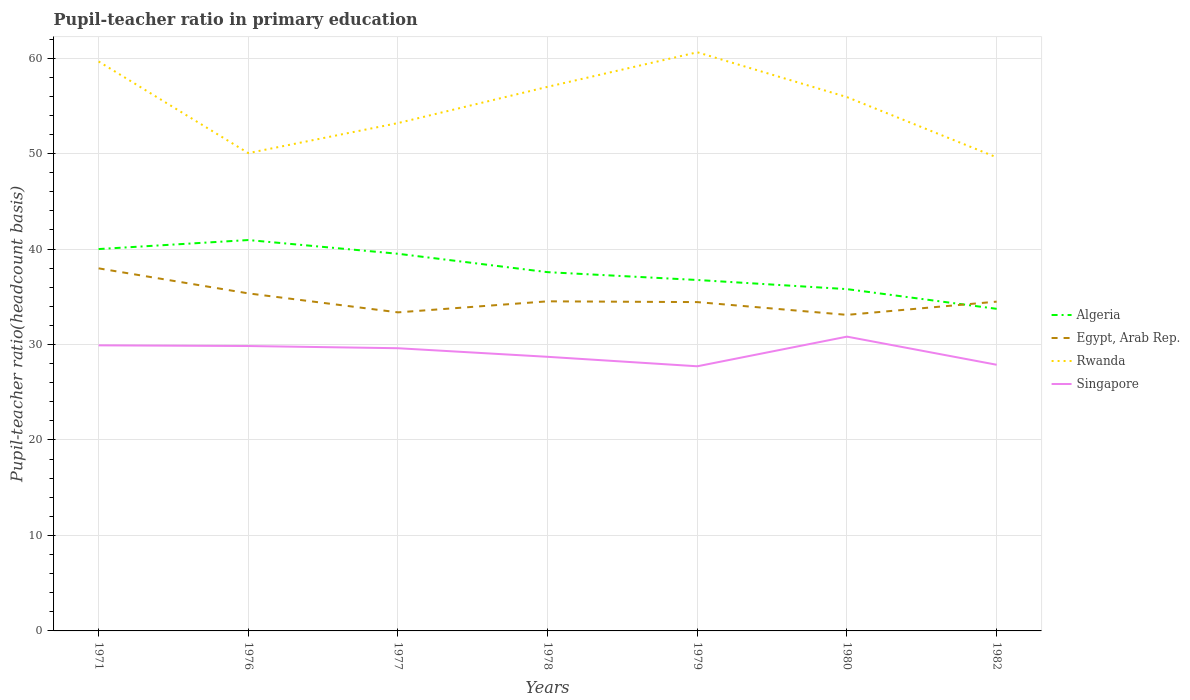How many different coloured lines are there?
Keep it short and to the point. 4. Across all years, what is the maximum pupil-teacher ratio in primary education in Algeria?
Give a very brief answer. 33.74. What is the total pupil-teacher ratio in primary education in Rwanda in the graph?
Offer a very short reply. 0.45. What is the difference between the highest and the second highest pupil-teacher ratio in primary education in Egypt, Arab Rep.?
Your response must be concise. 4.87. Is the pupil-teacher ratio in primary education in Algeria strictly greater than the pupil-teacher ratio in primary education in Singapore over the years?
Offer a terse response. No. How many years are there in the graph?
Make the answer very short. 7. What is the difference between two consecutive major ticks on the Y-axis?
Give a very brief answer. 10. Does the graph contain any zero values?
Provide a succinct answer. No. Does the graph contain grids?
Provide a short and direct response. Yes. Where does the legend appear in the graph?
Your response must be concise. Center right. What is the title of the graph?
Make the answer very short. Pupil-teacher ratio in primary education. Does "Luxembourg" appear as one of the legend labels in the graph?
Give a very brief answer. No. What is the label or title of the X-axis?
Keep it short and to the point. Years. What is the label or title of the Y-axis?
Provide a short and direct response. Pupil-teacher ratio(headcount basis). What is the Pupil-teacher ratio(headcount basis) of Algeria in 1971?
Keep it short and to the point. 40. What is the Pupil-teacher ratio(headcount basis) in Egypt, Arab Rep. in 1971?
Provide a short and direct response. 37.98. What is the Pupil-teacher ratio(headcount basis) in Rwanda in 1971?
Provide a short and direct response. 59.65. What is the Pupil-teacher ratio(headcount basis) of Singapore in 1971?
Make the answer very short. 29.92. What is the Pupil-teacher ratio(headcount basis) of Algeria in 1976?
Keep it short and to the point. 40.95. What is the Pupil-teacher ratio(headcount basis) of Egypt, Arab Rep. in 1976?
Your answer should be very brief. 35.36. What is the Pupil-teacher ratio(headcount basis) of Rwanda in 1976?
Your answer should be very brief. 50.05. What is the Pupil-teacher ratio(headcount basis) of Singapore in 1976?
Ensure brevity in your answer.  29.84. What is the Pupil-teacher ratio(headcount basis) of Algeria in 1977?
Give a very brief answer. 39.51. What is the Pupil-teacher ratio(headcount basis) of Egypt, Arab Rep. in 1977?
Give a very brief answer. 33.37. What is the Pupil-teacher ratio(headcount basis) of Rwanda in 1977?
Offer a very short reply. 53.2. What is the Pupil-teacher ratio(headcount basis) of Singapore in 1977?
Give a very brief answer. 29.61. What is the Pupil-teacher ratio(headcount basis) in Algeria in 1978?
Ensure brevity in your answer.  37.58. What is the Pupil-teacher ratio(headcount basis) in Egypt, Arab Rep. in 1978?
Make the answer very short. 34.53. What is the Pupil-teacher ratio(headcount basis) of Rwanda in 1978?
Ensure brevity in your answer.  57. What is the Pupil-teacher ratio(headcount basis) of Singapore in 1978?
Your answer should be very brief. 28.71. What is the Pupil-teacher ratio(headcount basis) of Algeria in 1979?
Keep it short and to the point. 36.76. What is the Pupil-teacher ratio(headcount basis) of Egypt, Arab Rep. in 1979?
Your response must be concise. 34.45. What is the Pupil-teacher ratio(headcount basis) of Rwanda in 1979?
Make the answer very short. 60.61. What is the Pupil-teacher ratio(headcount basis) of Singapore in 1979?
Your response must be concise. 27.72. What is the Pupil-teacher ratio(headcount basis) in Algeria in 1980?
Give a very brief answer. 35.8. What is the Pupil-teacher ratio(headcount basis) in Egypt, Arab Rep. in 1980?
Provide a short and direct response. 33.11. What is the Pupil-teacher ratio(headcount basis) in Rwanda in 1980?
Give a very brief answer. 55.92. What is the Pupil-teacher ratio(headcount basis) in Singapore in 1980?
Provide a short and direct response. 30.83. What is the Pupil-teacher ratio(headcount basis) in Algeria in 1982?
Give a very brief answer. 33.74. What is the Pupil-teacher ratio(headcount basis) in Egypt, Arab Rep. in 1982?
Your answer should be compact. 34.49. What is the Pupil-teacher ratio(headcount basis) in Rwanda in 1982?
Offer a very short reply. 49.61. What is the Pupil-teacher ratio(headcount basis) in Singapore in 1982?
Offer a terse response. 27.88. Across all years, what is the maximum Pupil-teacher ratio(headcount basis) in Algeria?
Make the answer very short. 40.95. Across all years, what is the maximum Pupil-teacher ratio(headcount basis) in Egypt, Arab Rep.?
Keep it short and to the point. 37.98. Across all years, what is the maximum Pupil-teacher ratio(headcount basis) of Rwanda?
Offer a very short reply. 60.61. Across all years, what is the maximum Pupil-teacher ratio(headcount basis) of Singapore?
Make the answer very short. 30.83. Across all years, what is the minimum Pupil-teacher ratio(headcount basis) of Algeria?
Provide a succinct answer. 33.74. Across all years, what is the minimum Pupil-teacher ratio(headcount basis) of Egypt, Arab Rep.?
Offer a terse response. 33.11. Across all years, what is the minimum Pupil-teacher ratio(headcount basis) in Rwanda?
Give a very brief answer. 49.61. Across all years, what is the minimum Pupil-teacher ratio(headcount basis) of Singapore?
Your response must be concise. 27.72. What is the total Pupil-teacher ratio(headcount basis) in Algeria in the graph?
Give a very brief answer. 264.34. What is the total Pupil-teacher ratio(headcount basis) of Egypt, Arab Rep. in the graph?
Your response must be concise. 243.28. What is the total Pupil-teacher ratio(headcount basis) in Rwanda in the graph?
Offer a terse response. 386.04. What is the total Pupil-teacher ratio(headcount basis) in Singapore in the graph?
Provide a short and direct response. 204.52. What is the difference between the Pupil-teacher ratio(headcount basis) of Algeria in 1971 and that in 1976?
Your answer should be compact. -0.95. What is the difference between the Pupil-teacher ratio(headcount basis) of Egypt, Arab Rep. in 1971 and that in 1976?
Offer a terse response. 2.62. What is the difference between the Pupil-teacher ratio(headcount basis) in Rwanda in 1971 and that in 1976?
Your answer should be very brief. 9.6. What is the difference between the Pupil-teacher ratio(headcount basis) in Singapore in 1971 and that in 1976?
Your response must be concise. 0.07. What is the difference between the Pupil-teacher ratio(headcount basis) of Algeria in 1971 and that in 1977?
Offer a terse response. 0.49. What is the difference between the Pupil-teacher ratio(headcount basis) in Egypt, Arab Rep. in 1971 and that in 1977?
Provide a succinct answer. 4.61. What is the difference between the Pupil-teacher ratio(headcount basis) in Rwanda in 1971 and that in 1977?
Your answer should be very brief. 6.45. What is the difference between the Pupil-teacher ratio(headcount basis) in Singapore in 1971 and that in 1977?
Keep it short and to the point. 0.3. What is the difference between the Pupil-teacher ratio(headcount basis) in Algeria in 1971 and that in 1978?
Offer a very short reply. 2.42. What is the difference between the Pupil-teacher ratio(headcount basis) in Egypt, Arab Rep. in 1971 and that in 1978?
Provide a short and direct response. 3.45. What is the difference between the Pupil-teacher ratio(headcount basis) of Rwanda in 1971 and that in 1978?
Offer a terse response. 2.66. What is the difference between the Pupil-teacher ratio(headcount basis) of Singapore in 1971 and that in 1978?
Offer a very short reply. 1.2. What is the difference between the Pupil-teacher ratio(headcount basis) of Algeria in 1971 and that in 1979?
Your answer should be very brief. 3.24. What is the difference between the Pupil-teacher ratio(headcount basis) of Egypt, Arab Rep. in 1971 and that in 1979?
Keep it short and to the point. 3.54. What is the difference between the Pupil-teacher ratio(headcount basis) of Rwanda in 1971 and that in 1979?
Your answer should be very brief. -0.96. What is the difference between the Pupil-teacher ratio(headcount basis) of Singapore in 1971 and that in 1979?
Your response must be concise. 2.19. What is the difference between the Pupil-teacher ratio(headcount basis) in Algeria in 1971 and that in 1980?
Make the answer very short. 4.2. What is the difference between the Pupil-teacher ratio(headcount basis) of Egypt, Arab Rep. in 1971 and that in 1980?
Keep it short and to the point. 4.87. What is the difference between the Pupil-teacher ratio(headcount basis) of Rwanda in 1971 and that in 1980?
Make the answer very short. 3.73. What is the difference between the Pupil-teacher ratio(headcount basis) of Singapore in 1971 and that in 1980?
Keep it short and to the point. -0.91. What is the difference between the Pupil-teacher ratio(headcount basis) of Algeria in 1971 and that in 1982?
Give a very brief answer. 6.26. What is the difference between the Pupil-teacher ratio(headcount basis) of Egypt, Arab Rep. in 1971 and that in 1982?
Your answer should be compact. 3.49. What is the difference between the Pupil-teacher ratio(headcount basis) of Rwanda in 1971 and that in 1982?
Your answer should be compact. 10.05. What is the difference between the Pupil-teacher ratio(headcount basis) in Singapore in 1971 and that in 1982?
Keep it short and to the point. 2.03. What is the difference between the Pupil-teacher ratio(headcount basis) in Algeria in 1976 and that in 1977?
Offer a very short reply. 1.44. What is the difference between the Pupil-teacher ratio(headcount basis) in Egypt, Arab Rep. in 1976 and that in 1977?
Your response must be concise. 1.99. What is the difference between the Pupil-teacher ratio(headcount basis) of Rwanda in 1976 and that in 1977?
Make the answer very short. -3.15. What is the difference between the Pupil-teacher ratio(headcount basis) of Singapore in 1976 and that in 1977?
Provide a succinct answer. 0.23. What is the difference between the Pupil-teacher ratio(headcount basis) of Algeria in 1976 and that in 1978?
Your answer should be compact. 3.36. What is the difference between the Pupil-teacher ratio(headcount basis) in Egypt, Arab Rep. in 1976 and that in 1978?
Your response must be concise. 0.83. What is the difference between the Pupil-teacher ratio(headcount basis) in Rwanda in 1976 and that in 1978?
Your answer should be very brief. -6.94. What is the difference between the Pupil-teacher ratio(headcount basis) in Singapore in 1976 and that in 1978?
Make the answer very short. 1.13. What is the difference between the Pupil-teacher ratio(headcount basis) in Algeria in 1976 and that in 1979?
Ensure brevity in your answer.  4.18. What is the difference between the Pupil-teacher ratio(headcount basis) of Egypt, Arab Rep. in 1976 and that in 1979?
Your answer should be very brief. 0.91. What is the difference between the Pupil-teacher ratio(headcount basis) in Rwanda in 1976 and that in 1979?
Offer a terse response. -10.56. What is the difference between the Pupil-teacher ratio(headcount basis) in Singapore in 1976 and that in 1979?
Give a very brief answer. 2.12. What is the difference between the Pupil-teacher ratio(headcount basis) of Algeria in 1976 and that in 1980?
Your response must be concise. 5.14. What is the difference between the Pupil-teacher ratio(headcount basis) in Egypt, Arab Rep. in 1976 and that in 1980?
Make the answer very short. 2.25. What is the difference between the Pupil-teacher ratio(headcount basis) in Rwanda in 1976 and that in 1980?
Keep it short and to the point. -5.87. What is the difference between the Pupil-teacher ratio(headcount basis) in Singapore in 1976 and that in 1980?
Ensure brevity in your answer.  -0.98. What is the difference between the Pupil-teacher ratio(headcount basis) in Algeria in 1976 and that in 1982?
Provide a short and direct response. 7.21. What is the difference between the Pupil-teacher ratio(headcount basis) in Egypt, Arab Rep. in 1976 and that in 1982?
Your answer should be compact. 0.87. What is the difference between the Pupil-teacher ratio(headcount basis) of Rwanda in 1976 and that in 1982?
Offer a very short reply. 0.45. What is the difference between the Pupil-teacher ratio(headcount basis) in Singapore in 1976 and that in 1982?
Keep it short and to the point. 1.96. What is the difference between the Pupil-teacher ratio(headcount basis) in Algeria in 1977 and that in 1978?
Give a very brief answer. 1.93. What is the difference between the Pupil-teacher ratio(headcount basis) of Egypt, Arab Rep. in 1977 and that in 1978?
Give a very brief answer. -1.16. What is the difference between the Pupil-teacher ratio(headcount basis) in Rwanda in 1977 and that in 1978?
Your answer should be compact. -3.8. What is the difference between the Pupil-teacher ratio(headcount basis) of Singapore in 1977 and that in 1978?
Your response must be concise. 0.9. What is the difference between the Pupil-teacher ratio(headcount basis) in Algeria in 1977 and that in 1979?
Keep it short and to the point. 2.75. What is the difference between the Pupil-teacher ratio(headcount basis) of Egypt, Arab Rep. in 1977 and that in 1979?
Make the answer very short. -1.08. What is the difference between the Pupil-teacher ratio(headcount basis) in Rwanda in 1977 and that in 1979?
Your answer should be compact. -7.42. What is the difference between the Pupil-teacher ratio(headcount basis) in Singapore in 1977 and that in 1979?
Give a very brief answer. 1.89. What is the difference between the Pupil-teacher ratio(headcount basis) of Algeria in 1977 and that in 1980?
Offer a very short reply. 3.7. What is the difference between the Pupil-teacher ratio(headcount basis) in Egypt, Arab Rep. in 1977 and that in 1980?
Your response must be concise. 0.26. What is the difference between the Pupil-teacher ratio(headcount basis) in Rwanda in 1977 and that in 1980?
Your answer should be very brief. -2.72. What is the difference between the Pupil-teacher ratio(headcount basis) in Singapore in 1977 and that in 1980?
Provide a short and direct response. -1.21. What is the difference between the Pupil-teacher ratio(headcount basis) of Algeria in 1977 and that in 1982?
Your answer should be very brief. 5.77. What is the difference between the Pupil-teacher ratio(headcount basis) of Egypt, Arab Rep. in 1977 and that in 1982?
Provide a succinct answer. -1.12. What is the difference between the Pupil-teacher ratio(headcount basis) of Rwanda in 1977 and that in 1982?
Offer a terse response. 3.59. What is the difference between the Pupil-teacher ratio(headcount basis) in Singapore in 1977 and that in 1982?
Keep it short and to the point. 1.73. What is the difference between the Pupil-teacher ratio(headcount basis) of Algeria in 1978 and that in 1979?
Provide a succinct answer. 0.82. What is the difference between the Pupil-teacher ratio(headcount basis) of Egypt, Arab Rep. in 1978 and that in 1979?
Make the answer very short. 0.08. What is the difference between the Pupil-teacher ratio(headcount basis) in Rwanda in 1978 and that in 1979?
Keep it short and to the point. -3.62. What is the difference between the Pupil-teacher ratio(headcount basis) in Singapore in 1978 and that in 1979?
Give a very brief answer. 0.99. What is the difference between the Pupil-teacher ratio(headcount basis) of Algeria in 1978 and that in 1980?
Your answer should be compact. 1.78. What is the difference between the Pupil-teacher ratio(headcount basis) of Egypt, Arab Rep. in 1978 and that in 1980?
Offer a terse response. 1.42. What is the difference between the Pupil-teacher ratio(headcount basis) in Rwanda in 1978 and that in 1980?
Your answer should be very brief. 1.08. What is the difference between the Pupil-teacher ratio(headcount basis) in Singapore in 1978 and that in 1980?
Ensure brevity in your answer.  -2.11. What is the difference between the Pupil-teacher ratio(headcount basis) in Algeria in 1978 and that in 1982?
Ensure brevity in your answer.  3.84. What is the difference between the Pupil-teacher ratio(headcount basis) in Egypt, Arab Rep. in 1978 and that in 1982?
Offer a very short reply. 0.03. What is the difference between the Pupil-teacher ratio(headcount basis) in Rwanda in 1978 and that in 1982?
Your response must be concise. 7.39. What is the difference between the Pupil-teacher ratio(headcount basis) of Singapore in 1978 and that in 1982?
Provide a short and direct response. 0.83. What is the difference between the Pupil-teacher ratio(headcount basis) of Algeria in 1979 and that in 1980?
Make the answer very short. 0.96. What is the difference between the Pupil-teacher ratio(headcount basis) in Egypt, Arab Rep. in 1979 and that in 1980?
Keep it short and to the point. 1.34. What is the difference between the Pupil-teacher ratio(headcount basis) in Rwanda in 1979 and that in 1980?
Offer a very short reply. 4.7. What is the difference between the Pupil-teacher ratio(headcount basis) of Singapore in 1979 and that in 1980?
Your answer should be compact. -3.11. What is the difference between the Pupil-teacher ratio(headcount basis) of Algeria in 1979 and that in 1982?
Make the answer very short. 3.02. What is the difference between the Pupil-teacher ratio(headcount basis) in Egypt, Arab Rep. in 1979 and that in 1982?
Offer a terse response. -0.05. What is the difference between the Pupil-teacher ratio(headcount basis) in Rwanda in 1979 and that in 1982?
Your response must be concise. 11.01. What is the difference between the Pupil-teacher ratio(headcount basis) in Singapore in 1979 and that in 1982?
Give a very brief answer. -0.16. What is the difference between the Pupil-teacher ratio(headcount basis) in Algeria in 1980 and that in 1982?
Provide a short and direct response. 2.06. What is the difference between the Pupil-teacher ratio(headcount basis) of Egypt, Arab Rep. in 1980 and that in 1982?
Ensure brevity in your answer.  -1.39. What is the difference between the Pupil-teacher ratio(headcount basis) in Rwanda in 1980 and that in 1982?
Offer a very short reply. 6.31. What is the difference between the Pupil-teacher ratio(headcount basis) in Singapore in 1980 and that in 1982?
Provide a short and direct response. 2.95. What is the difference between the Pupil-teacher ratio(headcount basis) in Algeria in 1971 and the Pupil-teacher ratio(headcount basis) in Egypt, Arab Rep. in 1976?
Keep it short and to the point. 4.64. What is the difference between the Pupil-teacher ratio(headcount basis) of Algeria in 1971 and the Pupil-teacher ratio(headcount basis) of Rwanda in 1976?
Your answer should be compact. -10.05. What is the difference between the Pupil-teacher ratio(headcount basis) in Algeria in 1971 and the Pupil-teacher ratio(headcount basis) in Singapore in 1976?
Give a very brief answer. 10.16. What is the difference between the Pupil-teacher ratio(headcount basis) in Egypt, Arab Rep. in 1971 and the Pupil-teacher ratio(headcount basis) in Rwanda in 1976?
Give a very brief answer. -12.07. What is the difference between the Pupil-teacher ratio(headcount basis) in Egypt, Arab Rep. in 1971 and the Pupil-teacher ratio(headcount basis) in Singapore in 1976?
Your answer should be compact. 8.14. What is the difference between the Pupil-teacher ratio(headcount basis) of Rwanda in 1971 and the Pupil-teacher ratio(headcount basis) of Singapore in 1976?
Your answer should be compact. 29.81. What is the difference between the Pupil-teacher ratio(headcount basis) of Algeria in 1971 and the Pupil-teacher ratio(headcount basis) of Egypt, Arab Rep. in 1977?
Offer a very short reply. 6.63. What is the difference between the Pupil-teacher ratio(headcount basis) of Algeria in 1971 and the Pupil-teacher ratio(headcount basis) of Rwanda in 1977?
Make the answer very short. -13.2. What is the difference between the Pupil-teacher ratio(headcount basis) of Algeria in 1971 and the Pupil-teacher ratio(headcount basis) of Singapore in 1977?
Provide a succinct answer. 10.39. What is the difference between the Pupil-teacher ratio(headcount basis) of Egypt, Arab Rep. in 1971 and the Pupil-teacher ratio(headcount basis) of Rwanda in 1977?
Make the answer very short. -15.22. What is the difference between the Pupil-teacher ratio(headcount basis) of Egypt, Arab Rep. in 1971 and the Pupil-teacher ratio(headcount basis) of Singapore in 1977?
Your response must be concise. 8.37. What is the difference between the Pupil-teacher ratio(headcount basis) in Rwanda in 1971 and the Pupil-teacher ratio(headcount basis) in Singapore in 1977?
Offer a terse response. 30.04. What is the difference between the Pupil-teacher ratio(headcount basis) in Algeria in 1971 and the Pupil-teacher ratio(headcount basis) in Egypt, Arab Rep. in 1978?
Your answer should be very brief. 5.47. What is the difference between the Pupil-teacher ratio(headcount basis) in Algeria in 1971 and the Pupil-teacher ratio(headcount basis) in Rwanda in 1978?
Ensure brevity in your answer.  -17. What is the difference between the Pupil-teacher ratio(headcount basis) of Algeria in 1971 and the Pupil-teacher ratio(headcount basis) of Singapore in 1978?
Provide a short and direct response. 11.29. What is the difference between the Pupil-teacher ratio(headcount basis) in Egypt, Arab Rep. in 1971 and the Pupil-teacher ratio(headcount basis) in Rwanda in 1978?
Your answer should be very brief. -19.02. What is the difference between the Pupil-teacher ratio(headcount basis) of Egypt, Arab Rep. in 1971 and the Pupil-teacher ratio(headcount basis) of Singapore in 1978?
Offer a very short reply. 9.27. What is the difference between the Pupil-teacher ratio(headcount basis) of Rwanda in 1971 and the Pupil-teacher ratio(headcount basis) of Singapore in 1978?
Give a very brief answer. 30.94. What is the difference between the Pupil-teacher ratio(headcount basis) in Algeria in 1971 and the Pupil-teacher ratio(headcount basis) in Egypt, Arab Rep. in 1979?
Ensure brevity in your answer.  5.56. What is the difference between the Pupil-teacher ratio(headcount basis) of Algeria in 1971 and the Pupil-teacher ratio(headcount basis) of Rwanda in 1979?
Provide a succinct answer. -20.61. What is the difference between the Pupil-teacher ratio(headcount basis) in Algeria in 1971 and the Pupil-teacher ratio(headcount basis) in Singapore in 1979?
Offer a very short reply. 12.28. What is the difference between the Pupil-teacher ratio(headcount basis) of Egypt, Arab Rep. in 1971 and the Pupil-teacher ratio(headcount basis) of Rwanda in 1979?
Provide a short and direct response. -22.63. What is the difference between the Pupil-teacher ratio(headcount basis) of Egypt, Arab Rep. in 1971 and the Pupil-teacher ratio(headcount basis) of Singapore in 1979?
Offer a very short reply. 10.26. What is the difference between the Pupil-teacher ratio(headcount basis) in Rwanda in 1971 and the Pupil-teacher ratio(headcount basis) in Singapore in 1979?
Offer a terse response. 31.93. What is the difference between the Pupil-teacher ratio(headcount basis) in Algeria in 1971 and the Pupil-teacher ratio(headcount basis) in Egypt, Arab Rep. in 1980?
Give a very brief answer. 6.89. What is the difference between the Pupil-teacher ratio(headcount basis) in Algeria in 1971 and the Pupil-teacher ratio(headcount basis) in Rwanda in 1980?
Offer a terse response. -15.92. What is the difference between the Pupil-teacher ratio(headcount basis) in Algeria in 1971 and the Pupil-teacher ratio(headcount basis) in Singapore in 1980?
Give a very brief answer. 9.17. What is the difference between the Pupil-teacher ratio(headcount basis) of Egypt, Arab Rep. in 1971 and the Pupil-teacher ratio(headcount basis) of Rwanda in 1980?
Make the answer very short. -17.94. What is the difference between the Pupil-teacher ratio(headcount basis) in Egypt, Arab Rep. in 1971 and the Pupil-teacher ratio(headcount basis) in Singapore in 1980?
Make the answer very short. 7.15. What is the difference between the Pupil-teacher ratio(headcount basis) of Rwanda in 1971 and the Pupil-teacher ratio(headcount basis) of Singapore in 1980?
Your answer should be very brief. 28.82. What is the difference between the Pupil-teacher ratio(headcount basis) of Algeria in 1971 and the Pupil-teacher ratio(headcount basis) of Egypt, Arab Rep. in 1982?
Ensure brevity in your answer.  5.51. What is the difference between the Pupil-teacher ratio(headcount basis) in Algeria in 1971 and the Pupil-teacher ratio(headcount basis) in Rwanda in 1982?
Make the answer very short. -9.61. What is the difference between the Pupil-teacher ratio(headcount basis) in Algeria in 1971 and the Pupil-teacher ratio(headcount basis) in Singapore in 1982?
Your answer should be very brief. 12.12. What is the difference between the Pupil-teacher ratio(headcount basis) in Egypt, Arab Rep. in 1971 and the Pupil-teacher ratio(headcount basis) in Rwanda in 1982?
Your answer should be compact. -11.63. What is the difference between the Pupil-teacher ratio(headcount basis) of Egypt, Arab Rep. in 1971 and the Pupil-teacher ratio(headcount basis) of Singapore in 1982?
Make the answer very short. 10.1. What is the difference between the Pupil-teacher ratio(headcount basis) in Rwanda in 1971 and the Pupil-teacher ratio(headcount basis) in Singapore in 1982?
Keep it short and to the point. 31.77. What is the difference between the Pupil-teacher ratio(headcount basis) of Algeria in 1976 and the Pupil-teacher ratio(headcount basis) of Egypt, Arab Rep. in 1977?
Keep it short and to the point. 7.58. What is the difference between the Pupil-teacher ratio(headcount basis) of Algeria in 1976 and the Pupil-teacher ratio(headcount basis) of Rwanda in 1977?
Your answer should be very brief. -12.25. What is the difference between the Pupil-teacher ratio(headcount basis) of Algeria in 1976 and the Pupil-teacher ratio(headcount basis) of Singapore in 1977?
Your answer should be very brief. 11.33. What is the difference between the Pupil-teacher ratio(headcount basis) in Egypt, Arab Rep. in 1976 and the Pupil-teacher ratio(headcount basis) in Rwanda in 1977?
Give a very brief answer. -17.84. What is the difference between the Pupil-teacher ratio(headcount basis) in Egypt, Arab Rep. in 1976 and the Pupil-teacher ratio(headcount basis) in Singapore in 1977?
Offer a very short reply. 5.75. What is the difference between the Pupil-teacher ratio(headcount basis) in Rwanda in 1976 and the Pupil-teacher ratio(headcount basis) in Singapore in 1977?
Keep it short and to the point. 20.44. What is the difference between the Pupil-teacher ratio(headcount basis) of Algeria in 1976 and the Pupil-teacher ratio(headcount basis) of Egypt, Arab Rep. in 1978?
Make the answer very short. 6.42. What is the difference between the Pupil-teacher ratio(headcount basis) in Algeria in 1976 and the Pupil-teacher ratio(headcount basis) in Rwanda in 1978?
Your answer should be compact. -16.05. What is the difference between the Pupil-teacher ratio(headcount basis) of Algeria in 1976 and the Pupil-teacher ratio(headcount basis) of Singapore in 1978?
Keep it short and to the point. 12.23. What is the difference between the Pupil-teacher ratio(headcount basis) in Egypt, Arab Rep. in 1976 and the Pupil-teacher ratio(headcount basis) in Rwanda in 1978?
Ensure brevity in your answer.  -21.64. What is the difference between the Pupil-teacher ratio(headcount basis) in Egypt, Arab Rep. in 1976 and the Pupil-teacher ratio(headcount basis) in Singapore in 1978?
Offer a terse response. 6.64. What is the difference between the Pupil-teacher ratio(headcount basis) of Rwanda in 1976 and the Pupil-teacher ratio(headcount basis) of Singapore in 1978?
Your response must be concise. 21.34. What is the difference between the Pupil-teacher ratio(headcount basis) in Algeria in 1976 and the Pupil-teacher ratio(headcount basis) in Egypt, Arab Rep. in 1979?
Your answer should be very brief. 6.5. What is the difference between the Pupil-teacher ratio(headcount basis) of Algeria in 1976 and the Pupil-teacher ratio(headcount basis) of Rwanda in 1979?
Offer a very short reply. -19.67. What is the difference between the Pupil-teacher ratio(headcount basis) of Algeria in 1976 and the Pupil-teacher ratio(headcount basis) of Singapore in 1979?
Your response must be concise. 13.22. What is the difference between the Pupil-teacher ratio(headcount basis) of Egypt, Arab Rep. in 1976 and the Pupil-teacher ratio(headcount basis) of Rwanda in 1979?
Your answer should be very brief. -25.26. What is the difference between the Pupil-teacher ratio(headcount basis) of Egypt, Arab Rep. in 1976 and the Pupil-teacher ratio(headcount basis) of Singapore in 1979?
Offer a terse response. 7.64. What is the difference between the Pupil-teacher ratio(headcount basis) in Rwanda in 1976 and the Pupil-teacher ratio(headcount basis) in Singapore in 1979?
Provide a succinct answer. 22.33. What is the difference between the Pupil-teacher ratio(headcount basis) in Algeria in 1976 and the Pupil-teacher ratio(headcount basis) in Egypt, Arab Rep. in 1980?
Provide a succinct answer. 7.84. What is the difference between the Pupil-teacher ratio(headcount basis) in Algeria in 1976 and the Pupil-teacher ratio(headcount basis) in Rwanda in 1980?
Make the answer very short. -14.97. What is the difference between the Pupil-teacher ratio(headcount basis) of Algeria in 1976 and the Pupil-teacher ratio(headcount basis) of Singapore in 1980?
Keep it short and to the point. 10.12. What is the difference between the Pupil-teacher ratio(headcount basis) in Egypt, Arab Rep. in 1976 and the Pupil-teacher ratio(headcount basis) in Rwanda in 1980?
Your response must be concise. -20.56. What is the difference between the Pupil-teacher ratio(headcount basis) of Egypt, Arab Rep. in 1976 and the Pupil-teacher ratio(headcount basis) of Singapore in 1980?
Your answer should be very brief. 4.53. What is the difference between the Pupil-teacher ratio(headcount basis) in Rwanda in 1976 and the Pupil-teacher ratio(headcount basis) in Singapore in 1980?
Keep it short and to the point. 19.22. What is the difference between the Pupil-teacher ratio(headcount basis) of Algeria in 1976 and the Pupil-teacher ratio(headcount basis) of Egypt, Arab Rep. in 1982?
Offer a very short reply. 6.45. What is the difference between the Pupil-teacher ratio(headcount basis) of Algeria in 1976 and the Pupil-teacher ratio(headcount basis) of Rwanda in 1982?
Offer a very short reply. -8.66. What is the difference between the Pupil-teacher ratio(headcount basis) in Algeria in 1976 and the Pupil-teacher ratio(headcount basis) in Singapore in 1982?
Make the answer very short. 13.07. What is the difference between the Pupil-teacher ratio(headcount basis) of Egypt, Arab Rep. in 1976 and the Pupil-teacher ratio(headcount basis) of Rwanda in 1982?
Provide a short and direct response. -14.25. What is the difference between the Pupil-teacher ratio(headcount basis) in Egypt, Arab Rep. in 1976 and the Pupil-teacher ratio(headcount basis) in Singapore in 1982?
Provide a short and direct response. 7.48. What is the difference between the Pupil-teacher ratio(headcount basis) of Rwanda in 1976 and the Pupil-teacher ratio(headcount basis) of Singapore in 1982?
Keep it short and to the point. 22.17. What is the difference between the Pupil-teacher ratio(headcount basis) in Algeria in 1977 and the Pupil-teacher ratio(headcount basis) in Egypt, Arab Rep. in 1978?
Your answer should be very brief. 4.98. What is the difference between the Pupil-teacher ratio(headcount basis) of Algeria in 1977 and the Pupil-teacher ratio(headcount basis) of Rwanda in 1978?
Ensure brevity in your answer.  -17.49. What is the difference between the Pupil-teacher ratio(headcount basis) of Algeria in 1977 and the Pupil-teacher ratio(headcount basis) of Singapore in 1978?
Make the answer very short. 10.79. What is the difference between the Pupil-teacher ratio(headcount basis) in Egypt, Arab Rep. in 1977 and the Pupil-teacher ratio(headcount basis) in Rwanda in 1978?
Your answer should be very brief. -23.63. What is the difference between the Pupil-teacher ratio(headcount basis) of Egypt, Arab Rep. in 1977 and the Pupil-teacher ratio(headcount basis) of Singapore in 1978?
Provide a short and direct response. 4.66. What is the difference between the Pupil-teacher ratio(headcount basis) of Rwanda in 1977 and the Pupil-teacher ratio(headcount basis) of Singapore in 1978?
Ensure brevity in your answer.  24.48. What is the difference between the Pupil-teacher ratio(headcount basis) in Algeria in 1977 and the Pupil-teacher ratio(headcount basis) in Egypt, Arab Rep. in 1979?
Offer a very short reply. 5.06. What is the difference between the Pupil-teacher ratio(headcount basis) of Algeria in 1977 and the Pupil-teacher ratio(headcount basis) of Rwanda in 1979?
Your answer should be very brief. -21.11. What is the difference between the Pupil-teacher ratio(headcount basis) in Algeria in 1977 and the Pupil-teacher ratio(headcount basis) in Singapore in 1979?
Provide a short and direct response. 11.79. What is the difference between the Pupil-teacher ratio(headcount basis) in Egypt, Arab Rep. in 1977 and the Pupil-teacher ratio(headcount basis) in Rwanda in 1979?
Offer a very short reply. -27.25. What is the difference between the Pupil-teacher ratio(headcount basis) of Egypt, Arab Rep. in 1977 and the Pupil-teacher ratio(headcount basis) of Singapore in 1979?
Keep it short and to the point. 5.65. What is the difference between the Pupil-teacher ratio(headcount basis) in Rwanda in 1977 and the Pupil-teacher ratio(headcount basis) in Singapore in 1979?
Give a very brief answer. 25.48. What is the difference between the Pupil-teacher ratio(headcount basis) of Algeria in 1977 and the Pupil-teacher ratio(headcount basis) of Egypt, Arab Rep. in 1980?
Offer a terse response. 6.4. What is the difference between the Pupil-teacher ratio(headcount basis) of Algeria in 1977 and the Pupil-teacher ratio(headcount basis) of Rwanda in 1980?
Offer a very short reply. -16.41. What is the difference between the Pupil-teacher ratio(headcount basis) in Algeria in 1977 and the Pupil-teacher ratio(headcount basis) in Singapore in 1980?
Your answer should be very brief. 8.68. What is the difference between the Pupil-teacher ratio(headcount basis) of Egypt, Arab Rep. in 1977 and the Pupil-teacher ratio(headcount basis) of Rwanda in 1980?
Keep it short and to the point. -22.55. What is the difference between the Pupil-teacher ratio(headcount basis) of Egypt, Arab Rep. in 1977 and the Pupil-teacher ratio(headcount basis) of Singapore in 1980?
Your answer should be compact. 2.54. What is the difference between the Pupil-teacher ratio(headcount basis) in Rwanda in 1977 and the Pupil-teacher ratio(headcount basis) in Singapore in 1980?
Your answer should be compact. 22.37. What is the difference between the Pupil-teacher ratio(headcount basis) of Algeria in 1977 and the Pupil-teacher ratio(headcount basis) of Egypt, Arab Rep. in 1982?
Your answer should be very brief. 5.02. What is the difference between the Pupil-teacher ratio(headcount basis) of Algeria in 1977 and the Pupil-teacher ratio(headcount basis) of Rwanda in 1982?
Provide a short and direct response. -10.1. What is the difference between the Pupil-teacher ratio(headcount basis) in Algeria in 1977 and the Pupil-teacher ratio(headcount basis) in Singapore in 1982?
Provide a short and direct response. 11.63. What is the difference between the Pupil-teacher ratio(headcount basis) in Egypt, Arab Rep. in 1977 and the Pupil-teacher ratio(headcount basis) in Rwanda in 1982?
Ensure brevity in your answer.  -16.24. What is the difference between the Pupil-teacher ratio(headcount basis) of Egypt, Arab Rep. in 1977 and the Pupil-teacher ratio(headcount basis) of Singapore in 1982?
Your response must be concise. 5.49. What is the difference between the Pupil-teacher ratio(headcount basis) of Rwanda in 1977 and the Pupil-teacher ratio(headcount basis) of Singapore in 1982?
Keep it short and to the point. 25.32. What is the difference between the Pupil-teacher ratio(headcount basis) in Algeria in 1978 and the Pupil-teacher ratio(headcount basis) in Egypt, Arab Rep. in 1979?
Your response must be concise. 3.14. What is the difference between the Pupil-teacher ratio(headcount basis) in Algeria in 1978 and the Pupil-teacher ratio(headcount basis) in Rwanda in 1979?
Make the answer very short. -23.03. What is the difference between the Pupil-teacher ratio(headcount basis) in Algeria in 1978 and the Pupil-teacher ratio(headcount basis) in Singapore in 1979?
Give a very brief answer. 9.86. What is the difference between the Pupil-teacher ratio(headcount basis) of Egypt, Arab Rep. in 1978 and the Pupil-teacher ratio(headcount basis) of Rwanda in 1979?
Make the answer very short. -26.09. What is the difference between the Pupil-teacher ratio(headcount basis) of Egypt, Arab Rep. in 1978 and the Pupil-teacher ratio(headcount basis) of Singapore in 1979?
Provide a short and direct response. 6.8. What is the difference between the Pupil-teacher ratio(headcount basis) of Rwanda in 1978 and the Pupil-teacher ratio(headcount basis) of Singapore in 1979?
Give a very brief answer. 29.27. What is the difference between the Pupil-teacher ratio(headcount basis) of Algeria in 1978 and the Pupil-teacher ratio(headcount basis) of Egypt, Arab Rep. in 1980?
Provide a succinct answer. 4.47. What is the difference between the Pupil-teacher ratio(headcount basis) of Algeria in 1978 and the Pupil-teacher ratio(headcount basis) of Rwanda in 1980?
Your answer should be very brief. -18.34. What is the difference between the Pupil-teacher ratio(headcount basis) in Algeria in 1978 and the Pupil-teacher ratio(headcount basis) in Singapore in 1980?
Offer a terse response. 6.75. What is the difference between the Pupil-teacher ratio(headcount basis) in Egypt, Arab Rep. in 1978 and the Pupil-teacher ratio(headcount basis) in Rwanda in 1980?
Ensure brevity in your answer.  -21.39. What is the difference between the Pupil-teacher ratio(headcount basis) of Egypt, Arab Rep. in 1978 and the Pupil-teacher ratio(headcount basis) of Singapore in 1980?
Your response must be concise. 3.7. What is the difference between the Pupil-teacher ratio(headcount basis) of Rwanda in 1978 and the Pupil-teacher ratio(headcount basis) of Singapore in 1980?
Make the answer very short. 26.17. What is the difference between the Pupil-teacher ratio(headcount basis) in Algeria in 1978 and the Pupil-teacher ratio(headcount basis) in Egypt, Arab Rep. in 1982?
Your response must be concise. 3.09. What is the difference between the Pupil-teacher ratio(headcount basis) in Algeria in 1978 and the Pupil-teacher ratio(headcount basis) in Rwanda in 1982?
Provide a short and direct response. -12.03. What is the difference between the Pupil-teacher ratio(headcount basis) of Algeria in 1978 and the Pupil-teacher ratio(headcount basis) of Singapore in 1982?
Keep it short and to the point. 9.7. What is the difference between the Pupil-teacher ratio(headcount basis) in Egypt, Arab Rep. in 1978 and the Pupil-teacher ratio(headcount basis) in Rwanda in 1982?
Your response must be concise. -15.08. What is the difference between the Pupil-teacher ratio(headcount basis) in Egypt, Arab Rep. in 1978 and the Pupil-teacher ratio(headcount basis) in Singapore in 1982?
Provide a short and direct response. 6.65. What is the difference between the Pupil-teacher ratio(headcount basis) in Rwanda in 1978 and the Pupil-teacher ratio(headcount basis) in Singapore in 1982?
Your answer should be very brief. 29.12. What is the difference between the Pupil-teacher ratio(headcount basis) of Algeria in 1979 and the Pupil-teacher ratio(headcount basis) of Egypt, Arab Rep. in 1980?
Ensure brevity in your answer.  3.65. What is the difference between the Pupil-teacher ratio(headcount basis) in Algeria in 1979 and the Pupil-teacher ratio(headcount basis) in Rwanda in 1980?
Give a very brief answer. -19.16. What is the difference between the Pupil-teacher ratio(headcount basis) in Algeria in 1979 and the Pupil-teacher ratio(headcount basis) in Singapore in 1980?
Keep it short and to the point. 5.93. What is the difference between the Pupil-teacher ratio(headcount basis) in Egypt, Arab Rep. in 1979 and the Pupil-teacher ratio(headcount basis) in Rwanda in 1980?
Your response must be concise. -21.47. What is the difference between the Pupil-teacher ratio(headcount basis) in Egypt, Arab Rep. in 1979 and the Pupil-teacher ratio(headcount basis) in Singapore in 1980?
Offer a terse response. 3.62. What is the difference between the Pupil-teacher ratio(headcount basis) in Rwanda in 1979 and the Pupil-teacher ratio(headcount basis) in Singapore in 1980?
Your answer should be very brief. 29.79. What is the difference between the Pupil-teacher ratio(headcount basis) in Algeria in 1979 and the Pupil-teacher ratio(headcount basis) in Egypt, Arab Rep. in 1982?
Your answer should be very brief. 2.27. What is the difference between the Pupil-teacher ratio(headcount basis) of Algeria in 1979 and the Pupil-teacher ratio(headcount basis) of Rwanda in 1982?
Make the answer very short. -12.85. What is the difference between the Pupil-teacher ratio(headcount basis) in Algeria in 1979 and the Pupil-teacher ratio(headcount basis) in Singapore in 1982?
Your response must be concise. 8.88. What is the difference between the Pupil-teacher ratio(headcount basis) in Egypt, Arab Rep. in 1979 and the Pupil-teacher ratio(headcount basis) in Rwanda in 1982?
Offer a very short reply. -15.16. What is the difference between the Pupil-teacher ratio(headcount basis) of Egypt, Arab Rep. in 1979 and the Pupil-teacher ratio(headcount basis) of Singapore in 1982?
Your response must be concise. 6.56. What is the difference between the Pupil-teacher ratio(headcount basis) of Rwanda in 1979 and the Pupil-teacher ratio(headcount basis) of Singapore in 1982?
Keep it short and to the point. 32.73. What is the difference between the Pupil-teacher ratio(headcount basis) of Algeria in 1980 and the Pupil-teacher ratio(headcount basis) of Egypt, Arab Rep. in 1982?
Your answer should be very brief. 1.31. What is the difference between the Pupil-teacher ratio(headcount basis) of Algeria in 1980 and the Pupil-teacher ratio(headcount basis) of Rwanda in 1982?
Your response must be concise. -13.8. What is the difference between the Pupil-teacher ratio(headcount basis) of Algeria in 1980 and the Pupil-teacher ratio(headcount basis) of Singapore in 1982?
Give a very brief answer. 7.92. What is the difference between the Pupil-teacher ratio(headcount basis) in Egypt, Arab Rep. in 1980 and the Pupil-teacher ratio(headcount basis) in Rwanda in 1982?
Offer a terse response. -16.5. What is the difference between the Pupil-teacher ratio(headcount basis) of Egypt, Arab Rep. in 1980 and the Pupil-teacher ratio(headcount basis) of Singapore in 1982?
Give a very brief answer. 5.23. What is the difference between the Pupil-teacher ratio(headcount basis) of Rwanda in 1980 and the Pupil-teacher ratio(headcount basis) of Singapore in 1982?
Offer a very short reply. 28.04. What is the average Pupil-teacher ratio(headcount basis) in Algeria per year?
Keep it short and to the point. 37.76. What is the average Pupil-teacher ratio(headcount basis) of Egypt, Arab Rep. per year?
Your answer should be very brief. 34.75. What is the average Pupil-teacher ratio(headcount basis) in Rwanda per year?
Your response must be concise. 55.15. What is the average Pupil-teacher ratio(headcount basis) of Singapore per year?
Offer a very short reply. 29.22. In the year 1971, what is the difference between the Pupil-teacher ratio(headcount basis) of Algeria and Pupil-teacher ratio(headcount basis) of Egypt, Arab Rep.?
Your answer should be very brief. 2.02. In the year 1971, what is the difference between the Pupil-teacher ratio(headcount basis) of Algeria and Pupil-teacher ratio(headcount basis) of Rwanda?
Provide a succinct answer. -19.65. In the year 1971, what is the difference between the Pupil-teacher ratio(headcount basis) in Algeria and Pupil-teacher ratio(headcount basis) in Singapore?
Provide a short and direct response. 10.09. In the year 1971, what is the difference between the Pupil-teacher ratio(headcount basis) in Egypt, Arab Rep. and Pupil-teacher ratio(headcount basis) in Rwanda?
Offer a very short reply. -21.67. In the year 1971, what is the difference between the Pupil-teacher ratio(headcount basis) in Egypt, Arab Rep. and Pupil-teacher ratio(headcount basis) in Singapore?
Ensure brevity in your answer.  8.06. In the year 1971, what is the difference between the Pupil-teacher ratio(headcount basis) in Rwanda and Pupil-teacher ratio(headcount basis) in Singapore?
Keep it short and to the point. 29.74. In the year 1976, what is the difference between the Pupil-teacher ratio(headcount basis) in Algeria and Pupil-teacher ratio(headcount basis) in Egypt, Arab Rep.?
Give a very brief answer. 5.59. In the year 1976, what is the difference between the Pupil-teacher ratio(headcount basis) in Algeria and Pupil-teacher ratio(headcount basis) in Rwanda?
Keep it short and to the point. -9.11. In the year 1976, what is the difference between the Pupil-teacher ratio(headcount basis) in Algeria and Pupil-teacher ratio(headcount basis) in Singapore?
Keep it short and to the point. 11.1. In the year 1976, what is the difference between the Pupil-teacher ratio(headcount basis) of Egypt, Arab Rep. and Pupil-teacher ratio(headcount basis) of Rwanda?
Keep it short and to the point. -14.69. In the year 1976, what is the difference between the Pupil-teacher ratio(headcount basis) in Egypt, Arab Rep. and Pupil-teacher ratio(headcount basis) in Singapore?
Keep it short and to the point. 5.51. In the year 1976, what is the difference between the Pupil-teacher ratio(headcount basis) of Rwanda and Pupil-teacher ratio(headcount basis) of Singapore?
Give a very brief answer. 20.21. In the year 1977, what is the difference between the Pupil-teacher ratio(headcount basis) of Algeria and Pupil-teacher ratio(headcount basis) of Egypt, Arab Rep.?
Provide a succinct answer. 6.14. In the year 1977, what is the difference between the Pupil-teacher ratio(headcount basis) of Algeria and Pupil-teacher ratio(headcount basis) of Rwanda?
Offer a terse response. -13.69. In the year 1977, what is the difference between the Pupil-teacher ratio(headcount basis) in Algeria and Pupil-teacher ratio(headcount basis) in Singapore?
Make the answer very short. 9.9. In the year 1977, what is the difference between the Pupil-teacher ratio(headcount basis) in Egypt, Arab Rep. and Pupil-teacher ratio(headcount basis) in Rwanda?
Give a very brief answer. -19.83. In the year 1977, what is the difference between the Pupil-teacher ratio(headcount basis) of Egypt, Arab Rep. and Pupil-teacher ratio(headcount basis) of Singapore?
Give a very brief answer. 3.76. In the year 1977, what is the difference between the Pupil-teacher ratio(headcount basis) of Rwanda and Pupil-teacher ratio(headcount basis) of Singapore?
Offer a terse response. 23.58. In the year 1978, what is the difference between the Pupil-teacher ratio(headcount basis) in Algeria and Pupil-teacher ratio(headcount basis) in Egypt, Arab Rep.?
Make the answer very short. 3.05. In the year 1978, what is the difference between the Pupil-teacher ratio(headcount basis) in Algeria and Pupil-teacher ratio(headcount basis) in Rwanda?
Offer a very short reply. -19.42. In the year 1978, what is the difference between the Pupil-teacher ratio(headcount basis) in Algeria and Pupil-teacher ratio(headcount basis) in Singapore?
Provide a succinct answer. 8.87. In the year 1978, what is the difference between the Pupil-teacher ratio(headcount basis) of Egypt, Arab Rep. and Pupil-teacher ratio(headcount basis) of Rwanda?
Your response must be concise. -22.47. In the year 1978, what is the difference between the Pupil-teacher ratio(headcount basis) in Egypt, Arab Rep. and Pupil-teacher ratio(headcount basis) in Singapore?
Offer a very short reply. 5.81. In the year 1978, what is the difference between the Pupil-teacher ratio(headcount basis) of Rwanda and Pupil-teacher ratio(headcount basis) of Singapore?
Your answer should be compact. 28.28. In the year 1979, what is the difference between the Pupil-teacher ratio(headcount basis) of Algeria and Pupil-teacher ratio(headcount basis) of Egypt, Arab Rep.?
Ensure brevity in your answer.  2.32. In the year 1979, what is the difference between the Pupil-teacher ratio(headcount basis) in Algeria and Pupil-teacher ratio(headcount basis) in Rwanda?
Provide a short and direct response. -23.85. In the year 1979, what is the difference between the Pupil-teacher ratio(headcount basis) in Algeria and Pupil-teacher ratio(headcount basis) in Singapore?
Ensure brevity in your answer.  9.04. In the year 1979, what is the difference between the Pupil-teacher ratio(headcount basis) in Egypt, Arab Rep. and Pupil-teacher ratio(headcount basis) in Rwanda?
Make the answer very short. -26.17. In the year 1979, what is the difference between the Pupil-teacher ratio(headcount basis) of Egypt, Arab Rep. and Pupil-teacher ratio(headcount basis) of Singapore?
Make the answer very short. 6.72. In the year 1979, what is the difference between the Pupil-teacher ratio(headcount basis) in Rwanda and Pupil-teacher ratio(headcount basis) in Singapore?
Your response must be concise. 32.89. In the year 1980, what is the difference between the Pupil-teacher ratio(headcount basis) in Algeria and Pupil-teacher ratio(headcount basis) in Egypt, Arab Rep.?
Give a very brief answer. 2.7. In the year 1980, what is the difference between the Pupil-teacher ratio(headcount basis) in Algeria and Pupil-teacher ratio(headcount basis) in Rwanda?
Make the answer very short. -20.11. In the year 1980, what is the difference between the Pupil-teacher ratio(headcount basis) in Algeria and Pupil-teacher ratio(headcount basis) in Singapore?
Your response must be concise. 4.98. In the year 1980, what is the difference between the Pupil-teacher ratio(headcount basis) of Egypt, Arab Rep. and Pupil-teacher ratio(headcount basis) of Rwanda?
Keep it short and to the point. -22.81. In the year 1980, what is the difference between the Pupil-teacher ratio(headcount basis) in Egypt, Arab Rep. and Pupil-teacher ratio(headcount basis) in Singapore?
Provide a succinct answer. 2.28. In the year 1980, what is the difference between the Pupil-teacher ratio(headcount basis) of Rwanda and Pupil-teacher ratio(headcount basis) of Singapore?
Make the answer very short. 25.09. In the year 1982, what is the difference between the Pupil-teacher ratio(headcount basis) in Algeria and Pupil-teacher ratio(headcount basis) in Egypt, Arab Rep.?
Your answer should be very brief. -0.75. In the year 1982, what is the difference between the Pupil-teacher ratio(headcount basis) in Algeria and Pupil-teacher ratio(headcount basis) in Rwanda?
Ensure brevity in your answer.  -15.87. In the year 1982, what is the difference between the Pupil-teacher ratio(headcount basis) of Algeria and Pupil-teacher ratio(headcount basis) of Singapore?
Your answer should be very brief. 5.86. In the year 1982, what is the difference between the Pupil-teacher ratio(headcount basis) in Egypt, Arab Rep. and Pupil-teacher ratio(headcount basis) in Rwanda?
Ensure brevity in your answer.  -15.11. In the year 1982, what is the difference between the Pupil-teacher ratio(headcount basis) in Egypt, Arab Rep. and Pupil-teacher ratio(headcount basis) in Singapore?
Offer a terse response. 6.61. In the year 1982, what is the difference between the Pupil-teacher ratio(headcount basis) in Rwanda and Pupil-teacher ratio(headcount basis) in Singapore?
Ensure brevity in your answer.  21.73. What is the ratio of the Pupil-teacher ratio(headcount basis) in Algeria in 1971 to that in 1976?
Your response must be concise. 0.98. What is the ratio of the Pupil-teacher ratio(headcount basis) of Egypt, Arab Rep. in 1971 to that in 1976?
Give a very brief answer. 1.07. What is the ratio of the Pupil-teacher ratio(headcount basis) in Rwanda in 1971 to that in 1976?
Give a very brief answer. 1.19. What is the ratio of the Pupil-teacher ratio(headcount basis) in Algeria in 1971 to that in 1977?
Ensure brevity in your answer.  1.01. What is the ratio of the Pupil-teacher ratio(headcount basis) in Egypt, Arab Rep. in 1971 to that in 1977?
Your response must be concise. 1.14. What is the ratio of the Pupil-teacher ratio(headcount basis) of Rwanda in 1971 to that in 1977?
Offer a very short reply. 1.12. What is the ratio of the Pupil-teacher ratio(headcount basis) of Singapore in 1971 to that in 1977?
Offer a very short reply. 1.01. What is the ratio of the Pupil-teacher ratio(headcount basis) of Algeria in 1971 to that in 1978?
Make the answer very short. 1.06. What is the ratio of the Pupil-teacher ratio(headcount basis) in Rwanda in 1971 to that in 1978?
Keep it short and to the point. 1.05. What is the ratio of the Pupil-teacher ratio(headcount basis) in Singapore in 1971 to that in 1978?
Your answer should be compact. 1.04. What is the ratio of the Pupil-teacher ratio(headcount basis) of Algeria in 1971 to that in 1979?
Provide a succinct answer. 1.09. What is the ratio of the Pupil-teacher ratio(headcount basis) of Egypt, Arab Rep. in 1971 to that in 1979?
Your response must be concise. 1.1. What is the ratio of the Pupil-teacher ratio(headcount basis) of Rwanda in 1971 to that in 1979?
Provide a succinct answer. 0.98. What is the ratio of the Pupil-teacher ratio(headcount basis) in Singapore in 1971 to that in 1979?
Offer a very short reply. 1.08. What is the ratio of the Pupil-teacher ratio(headcount basis) in Algeria in 1971 to that in 1980?
Your answer should be compact. 1.12. What is the ratio of the Pupil-teacher ratio(headcount basis) of Egypt, Arab Rep. in 1971 to that in 1980?
Offer a very short reply. 1.15. What is the ratio of the Pupil-teacher ratio(headcount basis) in Rwanda in 1971 to that in 1980?
Provide a short and direct response. 1.07. What is the ratio of the Pupil-teacher ratio(headcount basis) in Singapore in 1971 to that in 1980?
Give a very brief answer. 0.97. What is the ratio of the Pupil-teacher ratio(headcount basis) in Algeria in 1971 to that in 1982?
Provide a short and direct response. 1.19. What is the ratio of the Pupil-teacher ratio(headcount basis) in Egypt, Arab Rep. in 1971 to that in 1982?
Your answer should be compact. 1.1. What is the ratio of the Pupil-teacher ratio(headcount basis) of Rwanda in 1971 to that in 1982?
Keep it short and to the point. 1.2. What is the ratio of the Pupil-teacher ratio(headcount basis) of Singapore in 1971 to that in 1982?
Keep it short and to the point. 1.07. What is the ratio of the Pupil-teacher ratio(headcount basis) of Algeria in 1976 to that in 1977?
Give a very brief answer. 1.04. What is the ratio of the Pupil-teacher ratio(headcount basis) of Egypt, Arab Rep. in 1976 to that in 1977?
Keep it short and to the point. 1.06. What is the ratio of the Pupil-teacher ratio(headcount basis) in Rwanda in 1976 to that in 1977?
Provide a succinct answer. 0.94. What is the ratio of the Pupil-teacher ratio(headcount basis) in Singapore in 1976 to that in 1977?
Your answer should be compact. 1.01. What is the ratio of the Pupil-teacher ratio(headcount basis) of Algeria in 1976 to that in 1978?
Make the answer very short. 1.09. What is the ratio of the Pupil-teacher ratio(headcount basis) of Egypt, Arab Rep. in 1976 to that in 1978?
Give a very brief answer. 1.02. What is the ratio of the Pupil-teacher ratio(headcount basis) of Rwanda in 1976 to that in 1978?
Offer a terse response. 0.88. What is the ratio of the Pupil-teacher ratio(headcount basis) in Singapore in 1976 to that in 1978?
Offer a terse response. 1.04. What is the ratio of the Pupil-teacher ratio(headcount basis) in Algeria in 1976 to that in 1979?
Keep it short and to the point. 1.11. What is the ratio of the Pupil-teacher ratio(headcount basis) in Egypt, Arab Rep. in 1976 to that in 1979?
Ensure brevity in your answer.  1.03. What is the ratio of the Pupil-teacher ratio(headcount basis) in Rwanda in 1976 to that in 1979?
Make the answer very short. 0.83. What is the ratio of the Pupil-teacher ratio(headcount basis) of Singapore in 1976 to that in 1979?
Your answer should be very brief. 1.08. What is the ratio of the Pupil-teacher ratio(headcount basis) in Algeria in 1976 to that in 1980?
Offer a very short reply. 1.14. What is the ratio of the Pupil-teacher ratio(headcount basis) of Egypt, Arab Rep. in 1976 to that in 1980?
Your answer should be very brief. 1.07. What is the ratio of the Pupil-teacher ratio(headcount basis) in Rwanda in 1976 to that in 1980?
Your answer should be very brief. 0.9. What is the ratio of the Pupil-teacher ratio(headcount basis) in Singapore in 1976 to that in 1980?
Offer a very short reply. 0.97. What is the ratio of the Pupil-teacher ratio(headcount basis) of Algeria in 1976 to that in 1982?
Provide a succinct answer. 1.21. What is the ratio of the Pupil-teacher ratio(headcount basis) in Egypt, Arab Rep. in 1976 to that in 1982?
Make the answer very short. 1.03. What is the ratio of the Pupil-teacher ratio(headcount basis) of Rwanda in 1976 to that in 1982?
Offer a very short reply. 1.01. What is the ratio of the Pupil-teacher ratio(headcount basis) in Singapore in 1976 to that in 1982?
Your answer should be compact. 1.07. What is the ratio of the Pupil-teacher ratio(headcount basis) of Algeria in 1977 to that in 1978?
Your answer should be very brief. 1.05. What is the ratio of the Pupil-teacher ratio(headcount basis) in Egypt, Arab Rep. in 1977 to that in 1978?
Your answer should be compact. 0.97. What is the ratio of the Pupil-teacher ratio(headcount basis) of Rwanda in 1977 to that in 1978?
Your answer should be compact. 0.93. What is the ratio of the Pupil-teacher ratio(headcount basis) of Singapore in 1977 to that in 1978?
Make the answer very short. 1.03. What is the ratio of the Pupil-teacher ratio(headcount basis) in Algeria in 1977 to that in 1979?
Keep it short and to the point. 1.07. What is the ratio of the Pupil-teacher ratio(headcount basis) of Egypt, Arab Rep. in 1977 to that in 1979?
Give a very brief answer. 0.97. What is the ratio of the Pupil-teacher ratio(headcount basis) of Rwanda in 1977 to that in 1979?
Provide a short and direct response. 0.88. What is the ratio of the Pupil-teacher ratio(headcount basis) of Singapore in 1977 to that in 1979?
Your answer should be very brief. 1.07. What is the ratio of the Pupil-teacher ratio(headcount basis) in Algeria in 1977 to that in 1980?
Offer a very short reply. 1.1. What is the ratio of the Pupil-teacher ratio(headcount basis) in Egypt, Arab Rep. in 1977 to that in 1980?
Make the answer very short. 1.01. What is the ratio of the Pupil-teacher ratio(headcount basis) of Rwanda in 1977 to that in 1980?
Provide a succinct answer. 0.95. What is the ratio of the Pupil-teacher ratio(headcount basis) in Singapore in 1977 to that in 1980?
Offer a very short reply. 0.96. What is the ratio of the Pupil-teacher ratio(headcount basis) of Algeria in 1977 to that in 1982?
Keep it short and to the point. 1.17. What is the ratio of the Pupil-teacher ratio(headcount basis) of Egypt, Arab Rep. in 1977 to that in 1982?
Keep it short and to the point. 0.97. What is the ratio of the Pupil-teacher ratio(headcount basis) in Rwanda in 1977 to that in 1982?
Offer a terse response. 1.07. What is the ratio of the Pupil-teacher ratio(headcount basis) in Singapore in 1977 to that in 1982?
Give a very brief answer. 1.06. What is the ratio of the Pupil-teacher ratio(headcount basis) in Algeria in 1978 to that in 1979?
Offer a very short reply. 1.02. What is the ratio of the Pupil-teacher ratio(headcount basis) in Rwanda in 1978 to that in 1979?
Your response must be concise. 0.94. What is the ratio of the Pupil-teacher ratio(headcount basis) in Singapore in 1978 to that in 1979?
Give a very brief answer. 1.04. What is the ratio of the Pupil-teacher ratio(headcount basis) of Algeria in 1978 to that in 1980?
Make the answer very short. 1.05. What is the ratio of the Pupil-teacher ratio(headcount basis) of Egypt, Arab Rep. in 1978 to that in 1980?
Provide a short and direct response. 1.04. What is the ratio of the Pupil-teacher ratio(headcount basis) of Rwanda in 1978 to that in 1980?
Offer a very short reply. 1.02. What is the ratio of the Pupil-teacher ratio(headcount basis) in Singapore in 1978 to that in 1980?
Make the answer very short. 0.93. What is the ratio of the Pupil-teacher ratio(headcount basis) of Algeria in 1978 to that in 1982?
Provide a short and direct response. 1.11. What is the ratio of the Pupil-teacher ratio(headcount basis) in Rwanda in 1978 to that in 1982?
Give a very brief answer. 1.15. What is the ratio of the Pupil-teacher ratio(headcount basis) in Singapore in 1978 to that in 1982?
Keep it short and to the point. 1.03. What is the ratio of the Pupil-teacher ratio(headcount basis) of Algeria in 1979 to that in 1980?
Provide a short and direct response. 1.03. What is the ratio of the Pupil-teacher ratio(headcount basis) of Egypt, Arab Rep. in 1979 to that in 1980?
Your answer should be very brief. 1.04. What is the ratio of the Pupil-teacher ratio(headcount basis) in Rwanda in 1979 to that in 1980?
Ensure brevity in your answer.  1.08. What is the ratio of the Pupil-teacher ratio(headcount basis) in Singapore in 1979 to that in 1980?
Offer a terse response. 0.9. What is the ratio of the Pupil-teacher ratio(headcount basis) of Algeria in 1979 to that in 1982?
Provide a succinct answer. 1.09. What is the ratio of the Pupil-teacher ratio(headcount basis) in Egypt, Arab Rep. in 1979 to that in 1982?
Provide a short and direct response. 1. What is the ratio of the Pupil-teacher ratio(headcount basis) in Rwanda in 1979 to that in 1982?
Keep it short and to the point. 1.22. What is the ratio of the Pupil-teacher ratio(headcount basis) in Algeria in 1980 to that in 1982?
Make the answer very short. 1.06. What is the ratio of the Pupil-teacher ratio(headcount basis) in Egypt, Arab Rep. in 1980 to that in 1982?
Keep it short and to the point. 0.96. What is the ratio of the Pupil-teacher ratio(headcount basis) in Rwanda in 1980 to that in 1982?
Give a very brief answer. 1.13. What is the ratio of the Pupil-teacher ratio(headcount basis) of Singapore in 1980 to that in 1982?
Keep it short and to the point. 1.11. What is the difference between the highest and the second highest Pupil-teacher ratio(headcount basis) of Algeria?
Ensure brevity in your answer.  0.95. What is the difference between the highest and the second highest Pupil-teacher ratio(headcount basis) in Egypt, Arab Rep.?
Your answer should be very brief. 2.62. What is the difference between the highest and the second highest Pupil-teacher ratio(headcount basis) in Rwanda?
Provide a short and direct response. 0.96. What is the difference between the highest and the second highest Pupil-teacher ratio(headcount basis) in Singapore?
Ensure brevity in your answer.  0.91. What is the difference between the highest and the lowest Pupil-teacher ratio(headcount basis) in Algeria?
Ensure brevity in your answer.  7.21. What is the difference between the highest and the lowest Pupil-teacher ratio(headcount basis) of Egypt, Arab Rep.?
Provide a short and direct response. 4.87. What is the difference between the highest and the lowest Pupil-teacher ratio(headcount basis) of Rwanda?
Your answer should be very brief. 11.01. What is the difference between the highest and the lowest Pupil-teacher ratio(headcount basis) of Singapore?
Provide a succinct answer. 3.11. 